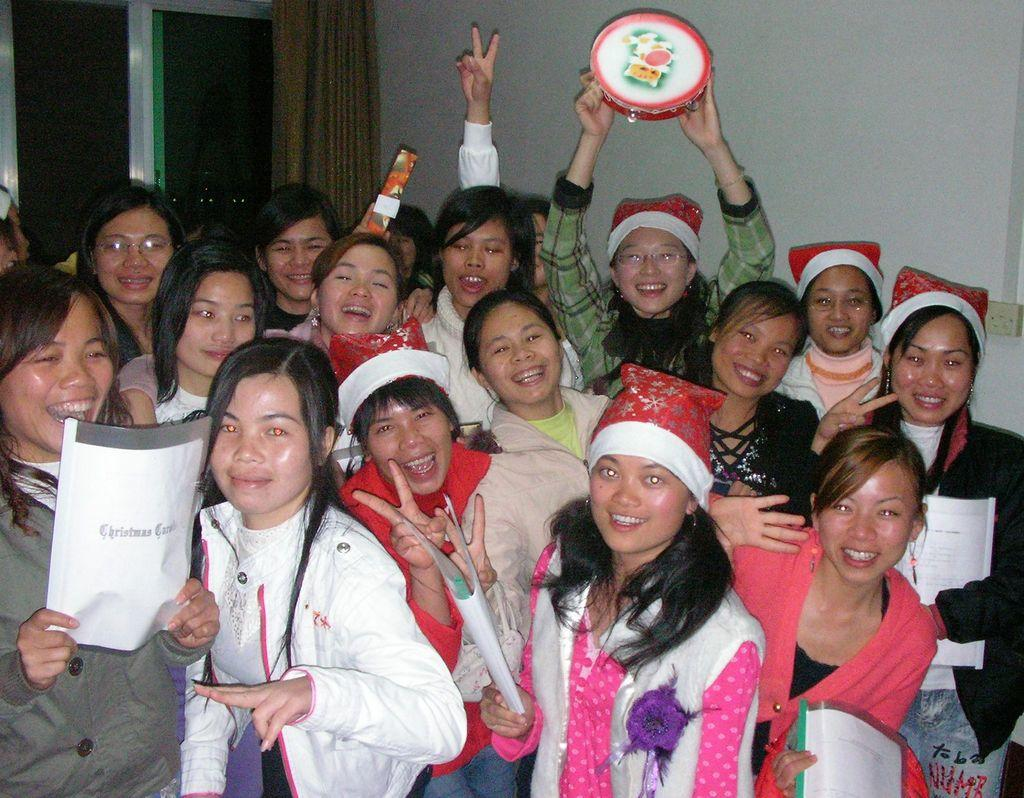How many people are in the image? There is a group of people in the image. What is the facial expression of the people in the image? The people are smiling. What can be seen in the background of the image? There is a wall and a window in the background of the image. Is there any window treatment present in the image? Yes, there is a curtain associated with the window. What type of tail can be seen on the people in the image? There are no tails present on the people in the image. What do the people regret in the image? There is no indication in the image that the people are experiencing regret. 